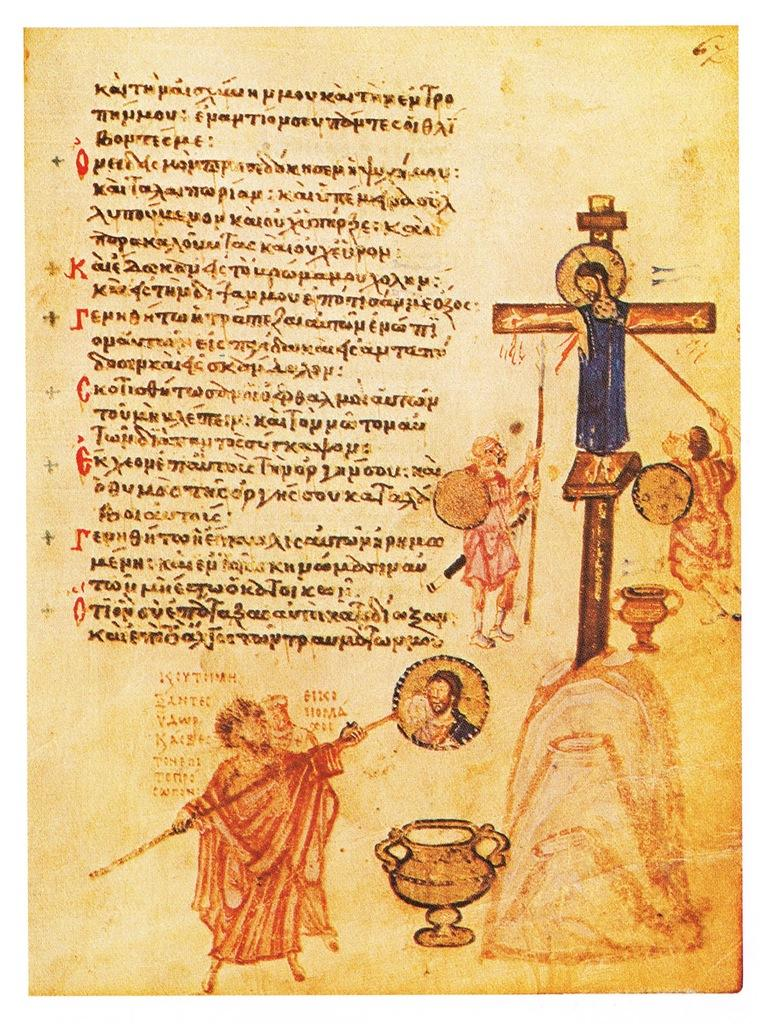What is present on the poster in the image? The poster contains text and images. Can you describe the content of the poster? Unfortunately, the specific content of the poster cannot be determined from the provided facts. What type of glue is used to attach the hose to the poster in the image? There is no hose or glue present in the image; it only contains a poster with text and images. How many bubbles can be seen floating around the poster in the image? There are no bubbles present in the image; it only contains a poster with text and images. 